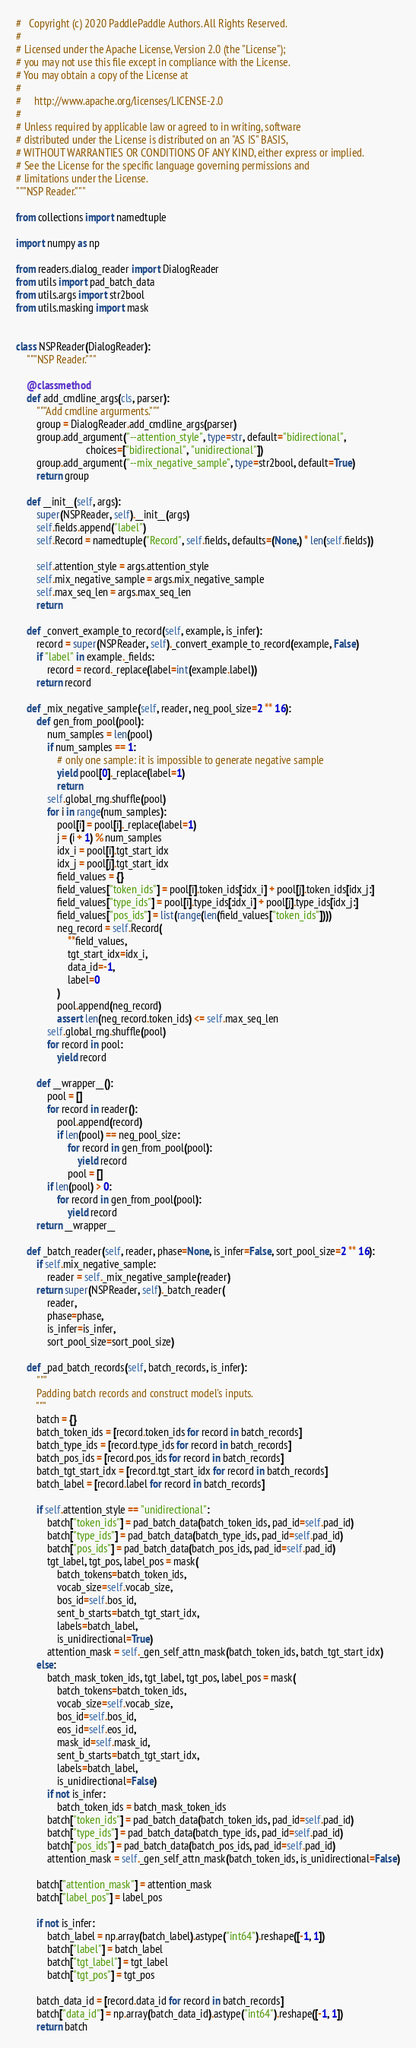<code> <loc_0><loc_0><loc_500><loc_500><_Python_>#   Copyright (c) 2020 PaddlePaddle Authors. All Rights Reserved.
#
# Licensed under the Apache License, Version 2.0 (the "License");
# you may not use this file except in compliance with the License.
# You may obtain a copy of the License at
#
#     http://www.apache.org/licenses/LICENSE-2.0
#
# Unless required by applicable law or agreed to in writing, software
# distributed under the License is distributed on an "AS IS" BASIS,
# WITHOUT WARRANTIES OR CONDITIONS OF ANY KIND, either express or implied.
# See the License for the specific language governing permissions and
# limitations under the License.
"""NSP Reader."""

from collections import namedtuple

import numpy as np

from readers.dialog_reader import DialogReader
from utils import pad_batch_data
from utils.args import str2bool
from utils.masking import mask


class NSPReader(DialogReader):
    """NSP Reader."""

    @classmethod
    def add_cmdline_args(cls, parser):
        """Add cmdline argurments."""
        group = DialogReader.add_cmdline_args(parser)
        group.add_argument("--attention_style", type=str, default="bidirectional",
                           choices=["bidirectional", "unidirectional"])
        group.add_argument("--mix_negative_sample", type=str2bool, default=True)
        return group

    def __init__(self, args):
        super(NSPReader, self).__init__(args)
        self.fields.append("label")
        self.Record = namedtuple("Record", self.fields, defaults=(None,) * len(self.fields))

        self.attention_style = args.attention_style
        self.mix_negative_sample = args.mix_negative_sample
        self.max_seq_len = args.max_seq_len
        return

    def _convert_example_to_record(self, example, is_infer):
        record = super(NSPReader, self)._convert_example_to_record(example, False)
        if "label" in example._fields:
            record = record._replace(label=int(example.label))
        return record

    def _mix_negative_sample(self, reader, neg_pool_size=2 ** 16):
        def gen_from_pool(pool):
            num_samples = len(pool)
            if num_samples == 1:
                # only one sample: it is impossible to generate negative sample
                yield pool[0]._replace(label=1)
                return
            self.global_rng.shuffle(pool)
            for i in range(num_samples):
                pool[i] = pool[i]._replace(label=1)
                j = (i + 1) % num_samples
                idx_i = pool[i].tgt_start_idx
                idx_j = pool[j].tgt_start_idx
                field_values = {}
                field_values["token_ids"] = pool[i].token_ids[:idx_i] + pool[j].token_ids[idx_j:]
                field_values["type_ids"] = pool[i].type_ids[:idx_i] + pool[j].type_ids[idx_j:]
                field_values["pos_ids"] = list(range(len(field_values["token_ids"])))
                neg_record = self.Record(
                    **field_values,
                    tgt_start_idx=idx_i,
                    data_id=-1,
                    label=0
                )
                pool.append(neg_record)
                assert len(neg_record.token_ids) <= self.max_seq_len
            self.global_rng.shuffle(pool)
            for record in pool:
                yield record

        def __wrapper__():
            pool = []
            for record in reader():
                pool.append(record)
                if len(pool) == neg_pool_size:
                    for record in gen_from_pool(pool):
                        yield record
                    pool = []
            if len(pool) > 0:
                for record in gen_from_pool(pool):
                    yield record
        return __wrapper__

    def _batch_reader(self, reader, phase=None, is_infer=False, sort_pool_size=2 ** 16):
        if self.mix_negative_sample:
            reader = self._mix_negative_sample(reader)
        return super(NSPReader, self)._batch_reader(
            reader,
            phase=phase,
            is_infer=is_infer,
            sort_pool_size=sort_pool_size)

    def _pad_batch_records(self, batch_records, is_infer):
        """
        Padding batch records and construct model's inputs.
        """
        batch = {}
        batch_token_ids = [record.token_ids for record in batch_records]
        batch_type_ids = [record.type_ids for record in batch_records]
        batch_pos_ids = [record.pos_ids for record in batch_records]
        batch_tgt_start_idx = [record.tgt_start_idx for record in batch_records]
        batch_label = [record.label for record in batch_records]

        if self.attention_style == "unidirectional":
            batch["token_ids"] = pad_batch_data(batch_token_ids, pad_id=self.pad_id)
            batch["type_ids"] = pad_batch_data(batch_type_ids, pad_id=self.pad_id)
            batch["pos_ids"] = pad_batch_data(batch_pos_ids, pad_id=self.pad_id)
            tgt_label, tgt_pos, label_pos = mask(
                batch_tokens=batch_token_ids,
                vocab_size=self.vocab_size,
                bos_id=self.bos_id,
                sent_b_starts=batch_tgt_start_idx,
                labels=batch_label,
                is_unidirectional=True)
            attention_mask = self._gen_self_attn_mask(batch_token_ids, batch_tgt_start_idx)
        else:
            batch_mask_token_ids, tgt_label, tgt_pos, label_pos = mask(
                batch_tokens=batch_token_ids,
                vocab_size=self.vocab_size,
                bos_id=self.bos_id,
                eos_id=self.eos_id,
                mask_id=self.mask_id,
                sent_b_starts=batch_tgt_start_idx,
                labels=batch_label,
                is_unidirectional=False)
            if not is_infer:
                batch_token_ids = batch_mask_token_ids
            batch["token_ids"] = pad_batch_data(batch_token_ids, pad_id=self.pad_id)
            batch["type_ids"] = pad_batch_data(batch_type_ids, pad_id=self.pad_id)
            batch["pos_ids"] = pad_batch_data(batch_pos_ids, pad_id=self.pad_id)
            attention_mask = self._gen_self_attn_mask(batch_token_ids, is_unidirectional=False)

        batch["attention_mask"] = attention_mask
        batch["label_pos"] = label_pos

        if not is_infer:
            batch_label = np.array(batch_label).astype("int64").reshape([-1, 1])
            batch["label"] = batch_label
            batch["tgt_label"] = tgt_label
            batch["tgt_pos"] = tgt_pos

        batch_data_id = [record.data_id for record in batch_records]
        batch["data_id"] = np.array(batch_data_id).astype("int64").reshape([-1, 1])
        return batch
</code> 